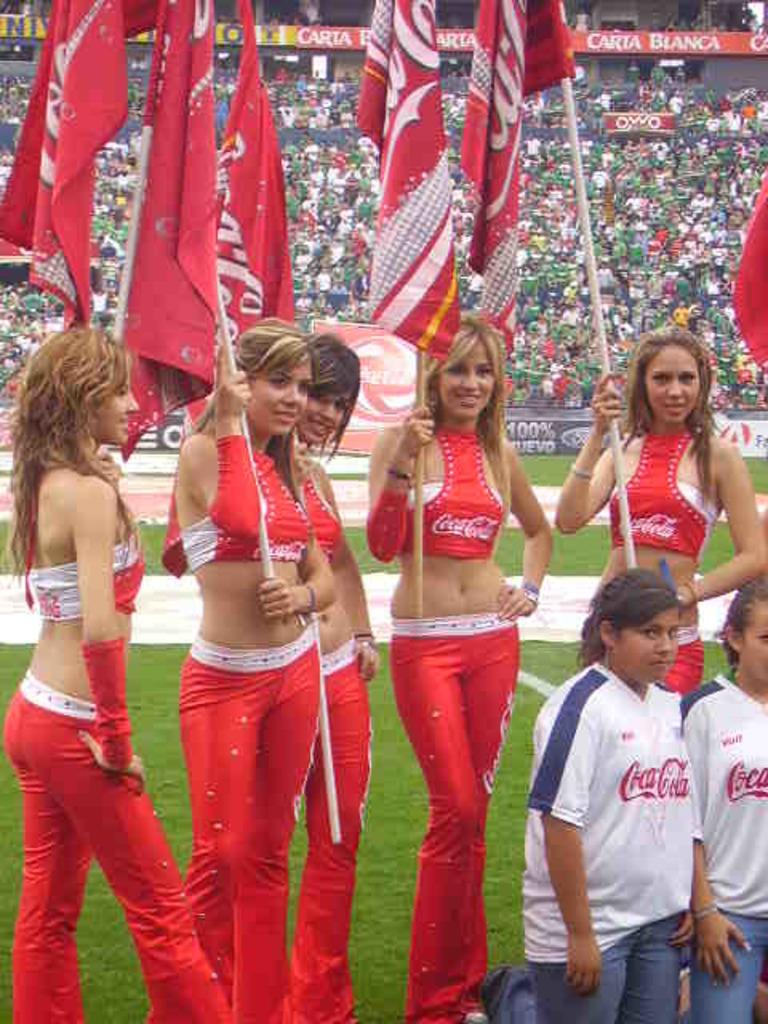<image>
Render a clear and concise summary of the photo. Some cheerleaders, all of whom are wearing coca-cola logos. 